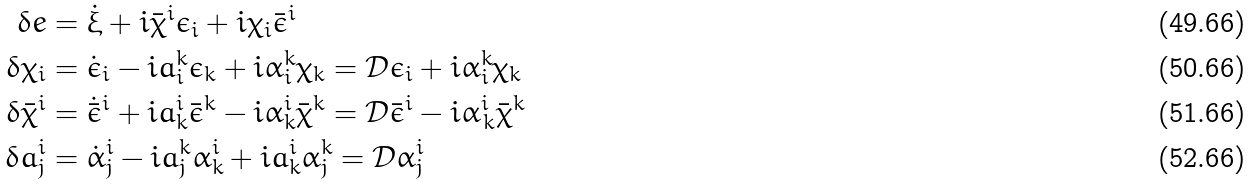<formula> <loc_0><loc_0><loc_500><loc_500>\delta e & = \dot { \xi } + i \bar { \chi } ^ { i } \epsilon _ { i } + i \chi _ { i } \bar { \epsilon } ^ { i } \\ \delta \chi _ { i } & = \dot { \epsilon } _ { i } - i a ^ { k } _ { i } \epsilon _ { k } + i \alpha ^ { k } _ { i } \chi _ { k } = \mathcal { D } \epsilon _ { i } + i \alpha ^ { k } _ { i } \chi _ { k } \\ \delta \bar { \chi } ^ { i } & = \dot { \bar { \epsilon } } ^ { i } + i a ^ { i } _ { k } \bar { \epsilon } ^ { k } - i \alpha ^ { i } _ { k } \bar { \chi } ^ { k } = \mathcal { D } \bar { \epsilon } ^ { i } - i \alpha ^ { i } _ { \, k } \bar { \chi } ^ { k } \\ \delta a ^ { i } _ { j } & = \dot { \alpha } ^ { i } _ { j } - i a _ { j } ^ { k } \alpha _ { k } ^ { i } + i a ^ { i } _ { k } \alpha ^ { k } _ { j } = \mathcal { D } \alpha ^ { i } _ { j }</formula> 